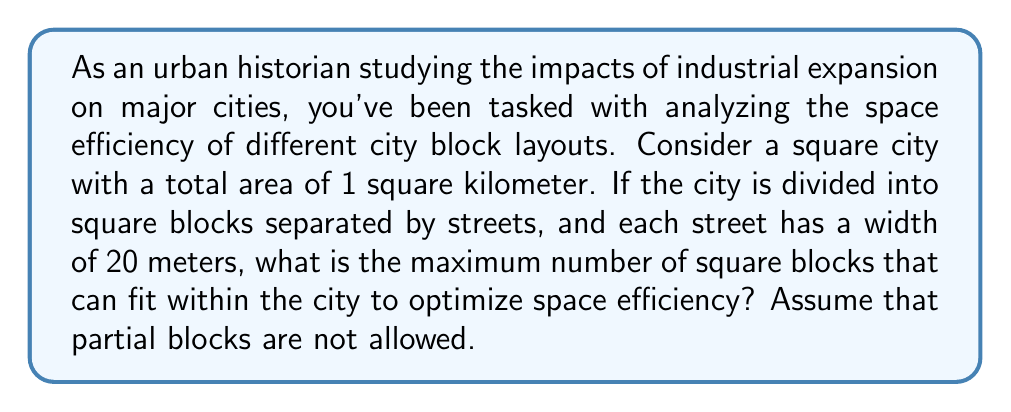Can you solve this math problem? To solve this problem, we need to follow these steps:

1) First, let's convert the city's area to square meters:
   1 km² = 1,000,000 m²

2) Now, we need to determine the side length of the city:
   $$\text{Side length} = \sqrt{1,000,000} = 1000\text{ m}$$

3) Let's define $x$ as the number of blocks along each side of the city. Then, the number of streets will be $x+1$.

4) The total width of the streets will be:
   $$20(x+1)\text{ m}$$

5) The remaining space for the blocks will be:
   $$1000 - 20(x+1)\text{ m}$$

6) This remaining space should be divisible by $x$ to create equal-sized blocks:
   $$\frac{1000 - 20(x+1)}{x} = \text{integer}$$

7) Simplifying this equation:
   $$\frac{980 - 20x}{x} = \text{integer}$$

8) We need to find the largest value of $x$ that satisfies this condition. We can do this by trial and error:

   For $x = 24$: $\frac{980 - 20(24)}{24} = \frac{500}{24} ≈ 20.83$ (not an integer)
   For $x = 23$: $\frac{980 - 20(23)}{23} = \frac{520}{23} ≈ 22.61$ (not an integer)
   For $x = 22$: $\frac{980 - 20(22)}{22} = \frac{540}{22} = 24.54545...$ (not an integer)
   For $x = 21$: $\frac{980 - 20(21)}{21} = \frac{560}{21} ≈ 26.67$ (not an integer)
   For $x = 20$: $\frac{980 - 20(20)}{20} = \frac{580}{20} = 29$ (an integer)

9) Therefore, the maximum number of blocks along each side is 20.

10) The total number of blocks in the city will be $20 * 20 = 400$.
Answer: The maximum number of square blocks that can fit within the city to optimize space efficiency is 400. 